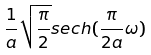<formula> <loc_0><loc_0><loc_500><loc_500>\frac { 1 } { a } \sqrt { \frac { \pi } { 2 } } s e c h ( \frac { \pi } { 2 a } \omega )</formula> 